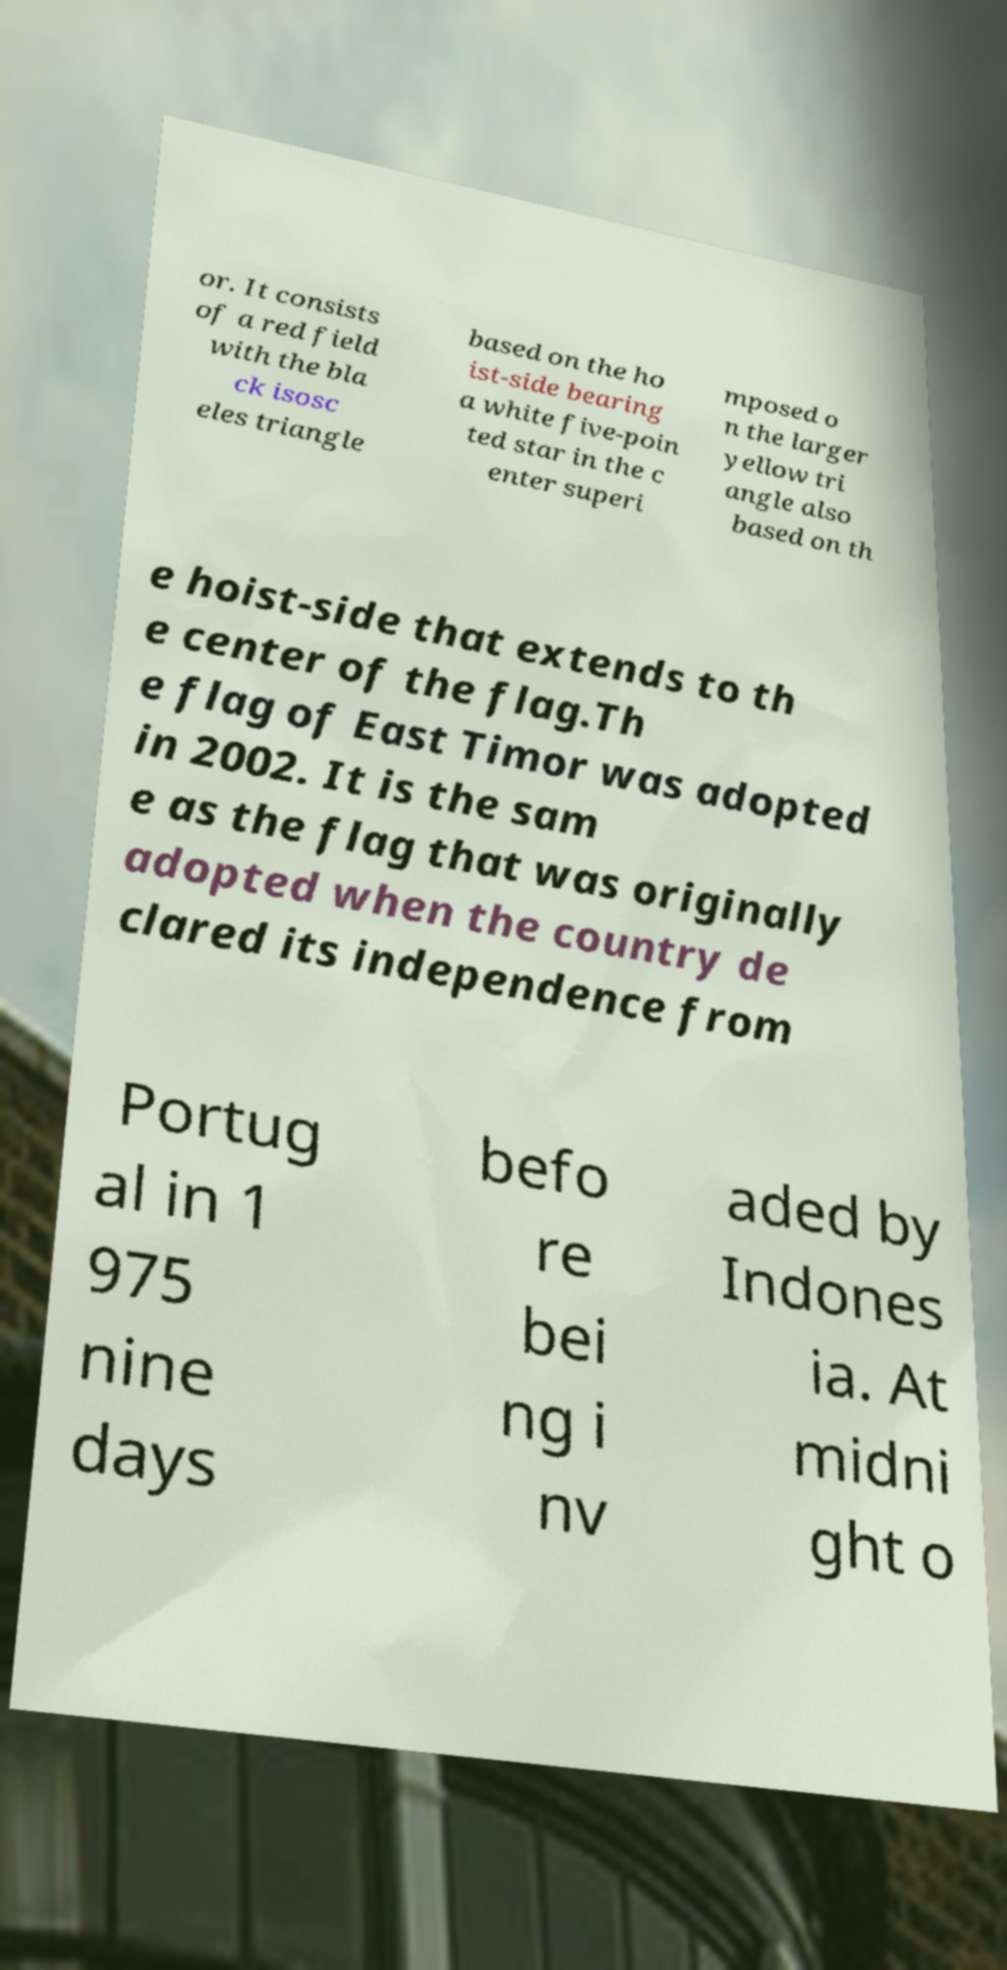Could you assist in decoding the text presented in this image and type it out clearly? or. It consists of a red field with the bla ck isosc eles triangle based on the ho ist-side bearing a white five-poin ted star in the c enter superi mposed o n the larger yellow tri angle also based on th e hoist-side that extends to th e center of the flag.Th e flag of East Timor was adopted in 2002. It is the sam e as the flag that was originally adopted when the country de clared its independence from Portug al in 1 975 nine days befo re bei ng i nv aded by Indones ia. At midni ght o 